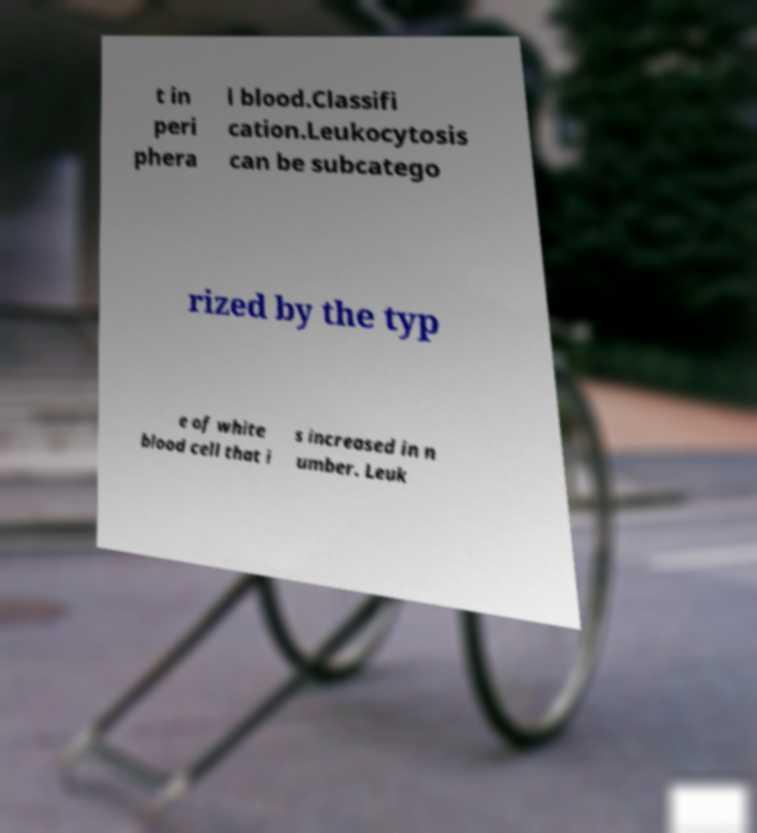I need the written content from this picture converted into text. Can you do that? t in peri phera l blood.Classifi cation.Leukocytosis can be subcatego rized by the typ e of white blood cell that i s increased in n umber. Leuk 